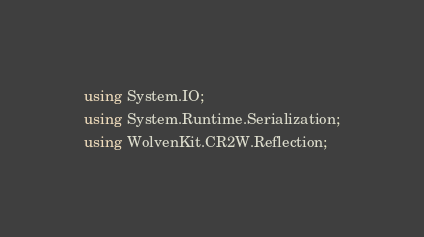Convert code to text. <code><loc_0><loc_0><loc_500><loc_500><_C#_>using System.IO;
using System.Runtime.Serialization;
using WolvenKit.CR2W.Reflection;</code> 